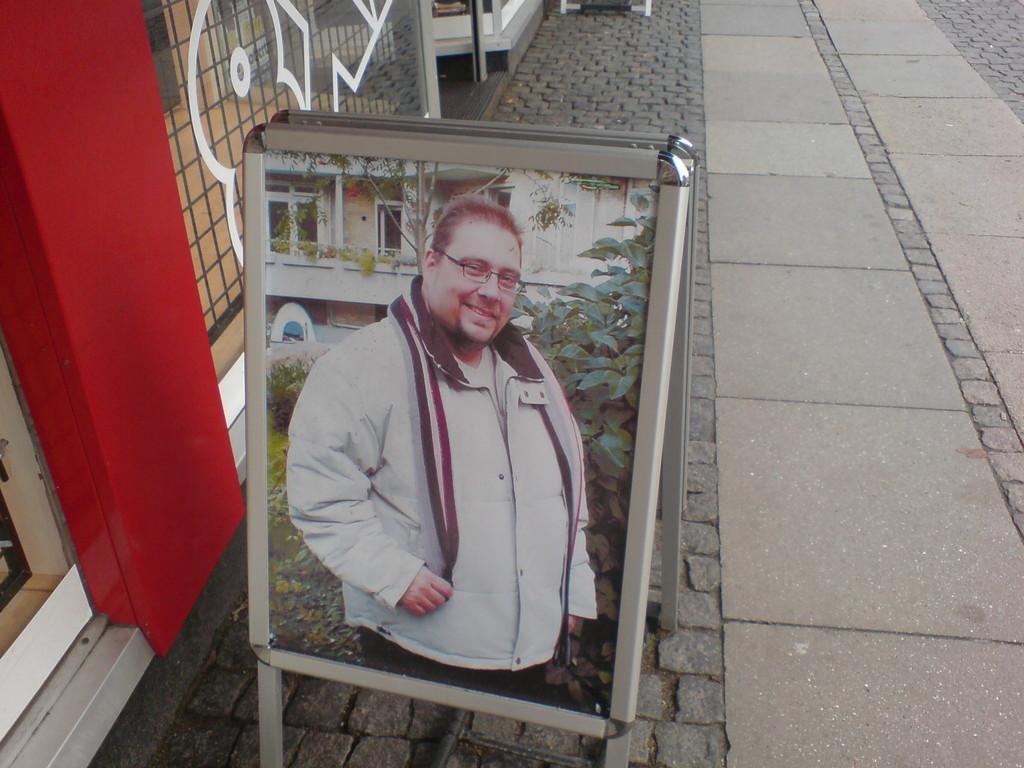Describe this image in one or two sentences. In this image I can see a board and on it I can see picture of a man, leaves and of a building. I can see he is wearing white colour jacket and specs. I can also see smile on his face. 